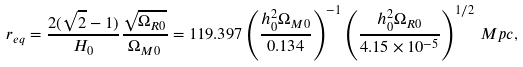<formula> <loc_0><loc_0><loc_500><loc_500>r _ { e q } = \frac { 2 ( \sqrt { 2 } - 1 ) } { H _ { 0 } } \frac { \sqrt { \Omega _ { R 0 } } } { \Omega _ { M 0 } } = 1 1 9 . 3 9 7 \left ( \frac { h _ { 0 } ^ { 2 } \Omega _ { M 0 } } { 0 . 1 3 4 } \right ) ^ { - 1 } \left ( \frac { h _ { 0 } ^ { 2 } \Omega _ { R 0 } } { 4 . 1 5 \times 1 0 ^ { - 5 } } \right ) ^ { 1 / 2 } \, M p c ,</formula> 